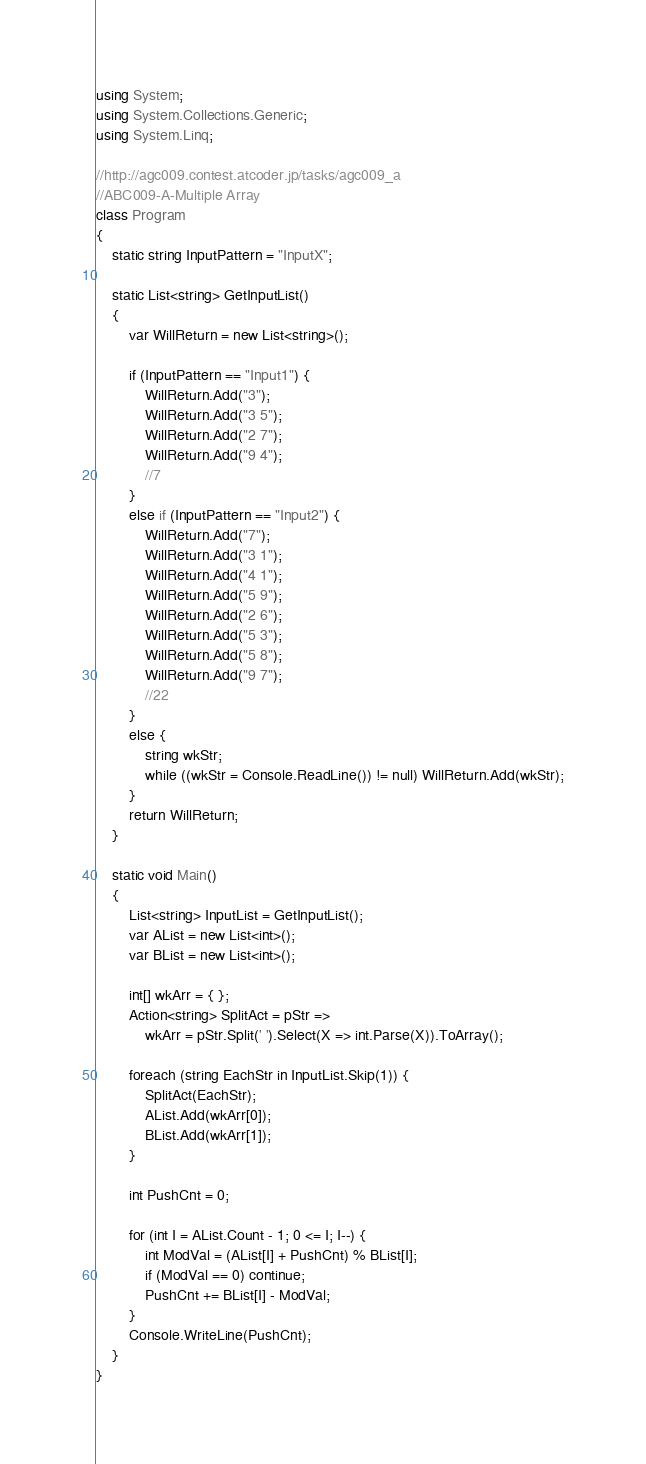Convert code to text. <code><loc_0><loc_0><loc_500><loc_500><_C#_>using System;
using System.Collections.Generic;
using System.Linq;

//http://agc009.contest.atcoder.jp/tasks/agc009_a
//ABC009-A-Multiple Array
class Program
{
    static string InputPattern = "InputX";

    static List<string> GetInputList()
    {
        var WillReturn = new List<string>();

        if (InputPattern == "Input1") {
            WillReturn.Add("3");
            WillReturn.Add("3 5");
            WillReturn.Add("2 7");
            WillReturn.Add("9 4");
            //7
        }
        else if (InputPattern == "Input2") {
            WillReturn.Add("7");
            WillReturn.Add("3 1");
            WillReturn.Add("4 1");
            WillReturn.Add("5 9");
            WillReturn.Add("2 6");
            WillReturn.Add("5 3");
            WillReturn.Add("5 8");
            WillReturn.Add("9 7");
            //22
        }
        else {
            string wkStr;
            while ((wkStr = Console.ReadLine()) != null) WillReturn.Add(wkStr);
        }
        return WillReturn;
    }

    static void Main()
    {
        List<string> InputList = GetInputList();
        var AList = new List<int>();
        var BList = new List<int>();

        int[] wkArr = { };
        Action<string> SplitAct = pStr =>
            wkArr = pStr.Split(' ').Select(X => int.Parse(X)).ToArray();

        foreach (string EachStr in InputList.Skip(1)) {
            SplitAct(EachStr);
            AList.Add(wkArr[0]);
            BList.Add(wkArr[1]);
        }

        int PushCnt = 0;

        for (int I = AList.Count - 1; 0 <= I; I--) {
            int ModVal = (AList[I] + PushCnt) % BList[I];
            if (ModVal == 0) continue;
            PushCnt += BList[I] - ModVal;
        }
        Console.WriteLine(PushCnt);
    }
}
</code> 